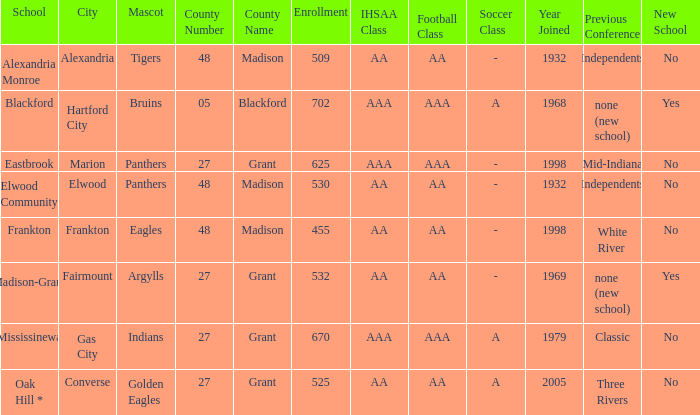What is teh ihsaa class/football/soccer when the location is alexandria? AA / AA / -. 